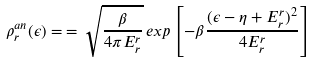Convert formula to latex. <formula><loc_0><loc_0><loc_500><loc_500>\rho ^ { a n } _ { r } ( \epsilon ) = \, = \, \sqrt { \frac { \beta } { 4 \pi E ^ { r } _ { r } } } \, e x p \left [ - \beta \frac { ( \epsilon - \eta + E ^ { r } _ { r } ) ^ { 2 } } { 4 E ^ { r } _ { r } } \right ]</formula> 